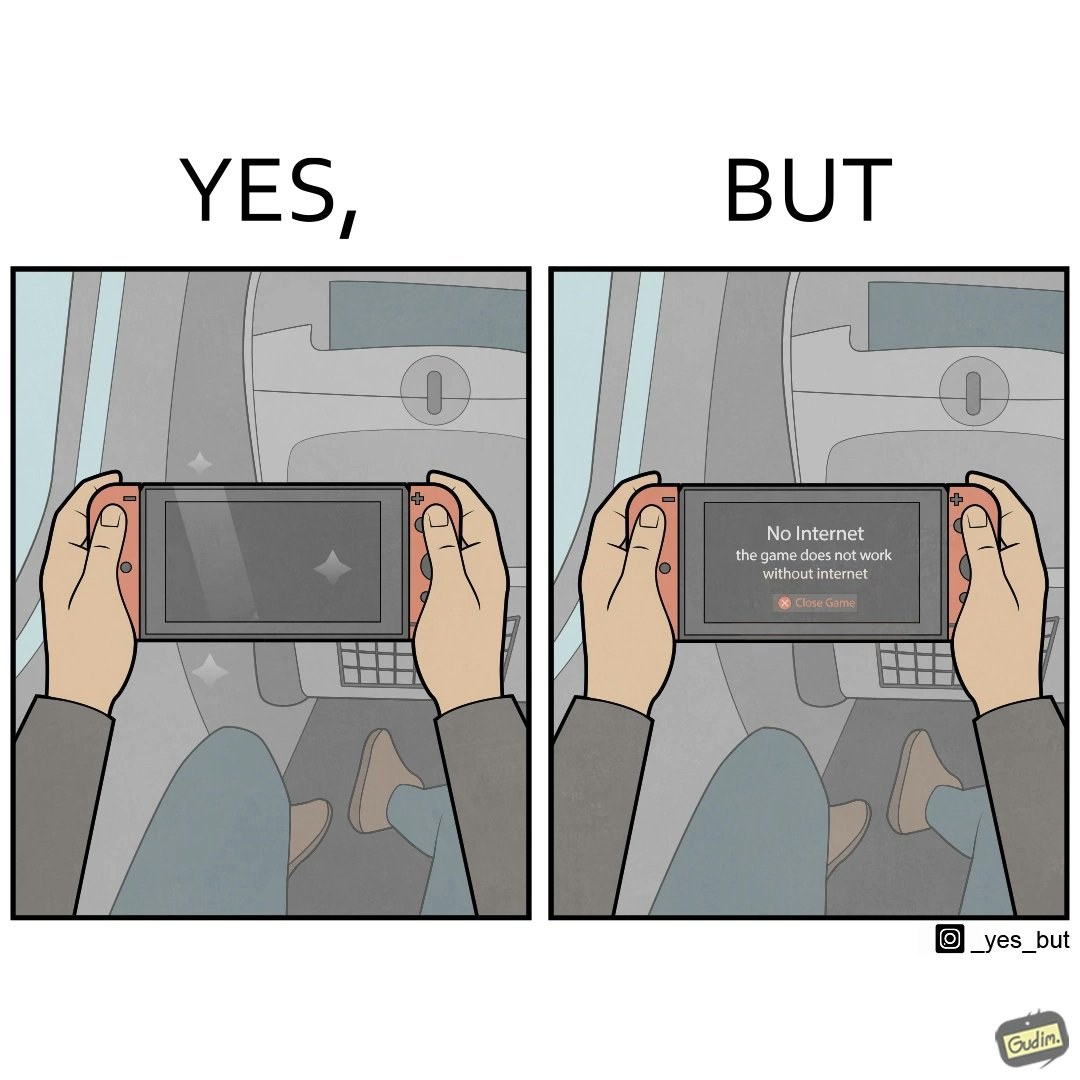Describe what you see in the left and right parts of this image. In the left part of the image: a person sitting in a flight seat, with a gaming console in the person's hands. In the right part of the image: a person sitting in a flight seat, with a gaming console in the person's hands, with a message which shows "No Internet, the game does not work without internet". 